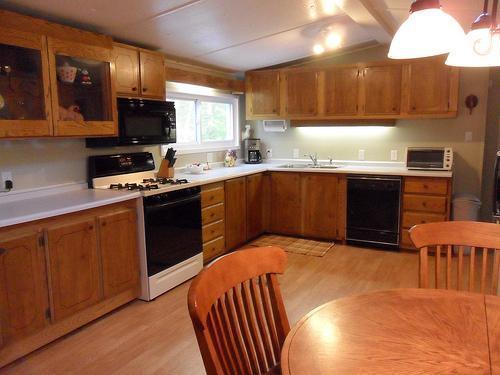How many chairs are in the picture?
Give a very brief answer. 2. How many dishwashers are in the photo?
Give a very brief answer. 1. 